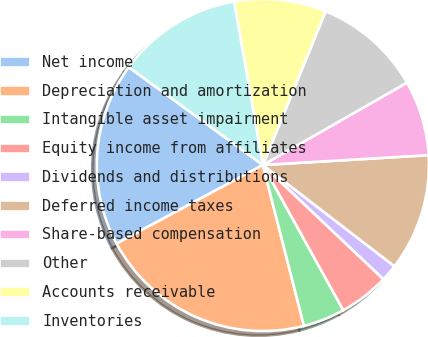Convert chart. <chart><loc_0><loc_0><loc_500><loc_500><pie_chart><fcel>Net income<fcel>Depreciation and amortization<fcel>Intangible asset impairment<fcel>Equity income from affiliates<fcel>Dividends and distributions<fcel>Deferred income taxes<fcel>Share-based compensation<fcel>Other<fcel>Accounts receivable<fcel>Inventories<nl><fcel>17.88%<fcel>21.13%<fcel>4.07%<fcel>4.88%<fcel>1.63%<fcel>11.38%<fcel>7.32%<fcel>10.57%<fcel>8.94%<fcel>12.19%<nl></chart> 